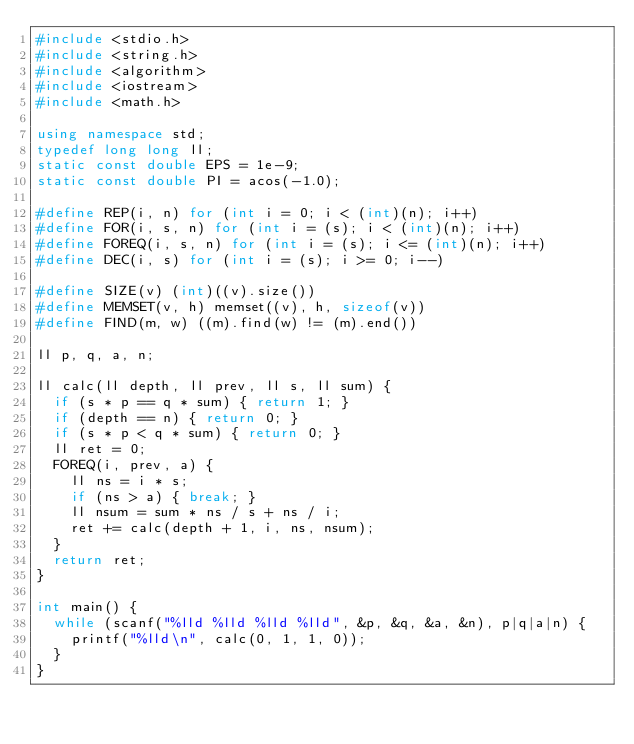<code> <loc_0><loc_0><loc_500><loc_500><_C++_>#include <stdio.h>
#include <string.h>
#include <algorithm>
#include <iostream>
#include <math.h>

using namespace std;
typedef long long ll;
static const double EPS = 1e-9;
static const double PI = acos(-1.0);

#define REP(i, n) for (int i = 0; i < (int)(n); i++)
#define FOR(i, s, n) for (int i = (s); i < (int)(n); i++)
#define FOREQ(i, s, n) for (int i = (s); i <= (int)(n); i++)
#define DEC(i, s) for (int i = (s); i >= 0; i--)

#define SIZE(v) (int)((v).size())
#define MEMSET(v, h) memset((v), h, sizeof(v))
#define FIND(m, w) ((m).find(w) != (m).end())

ll p, q, a, n;

ll calc(ll depth, ll prev, ll s, ll sum) {
  if (s * p == q * sum) { return 1; }
  if (depth == n) { return 0; }
  if (s * p < q * sum) { return 0; }
  ll ret = 0;
  FOREQ(i, prev, a) {
    ll ns = i * s;
    if (ns > a) { break; }
    ll nsum = sum * ns / s + ns / i;
    ret += calc(depth + 1, i, ns, nsum);
  }
  return ret;
}

int main() {
  while (scanf("%lld %lld %lld %lld", &p, &q, &a, &n), p|q|a|n) {
    printf("%lld\n", calc(0, 1, 1, 0));
  }
}</code> 